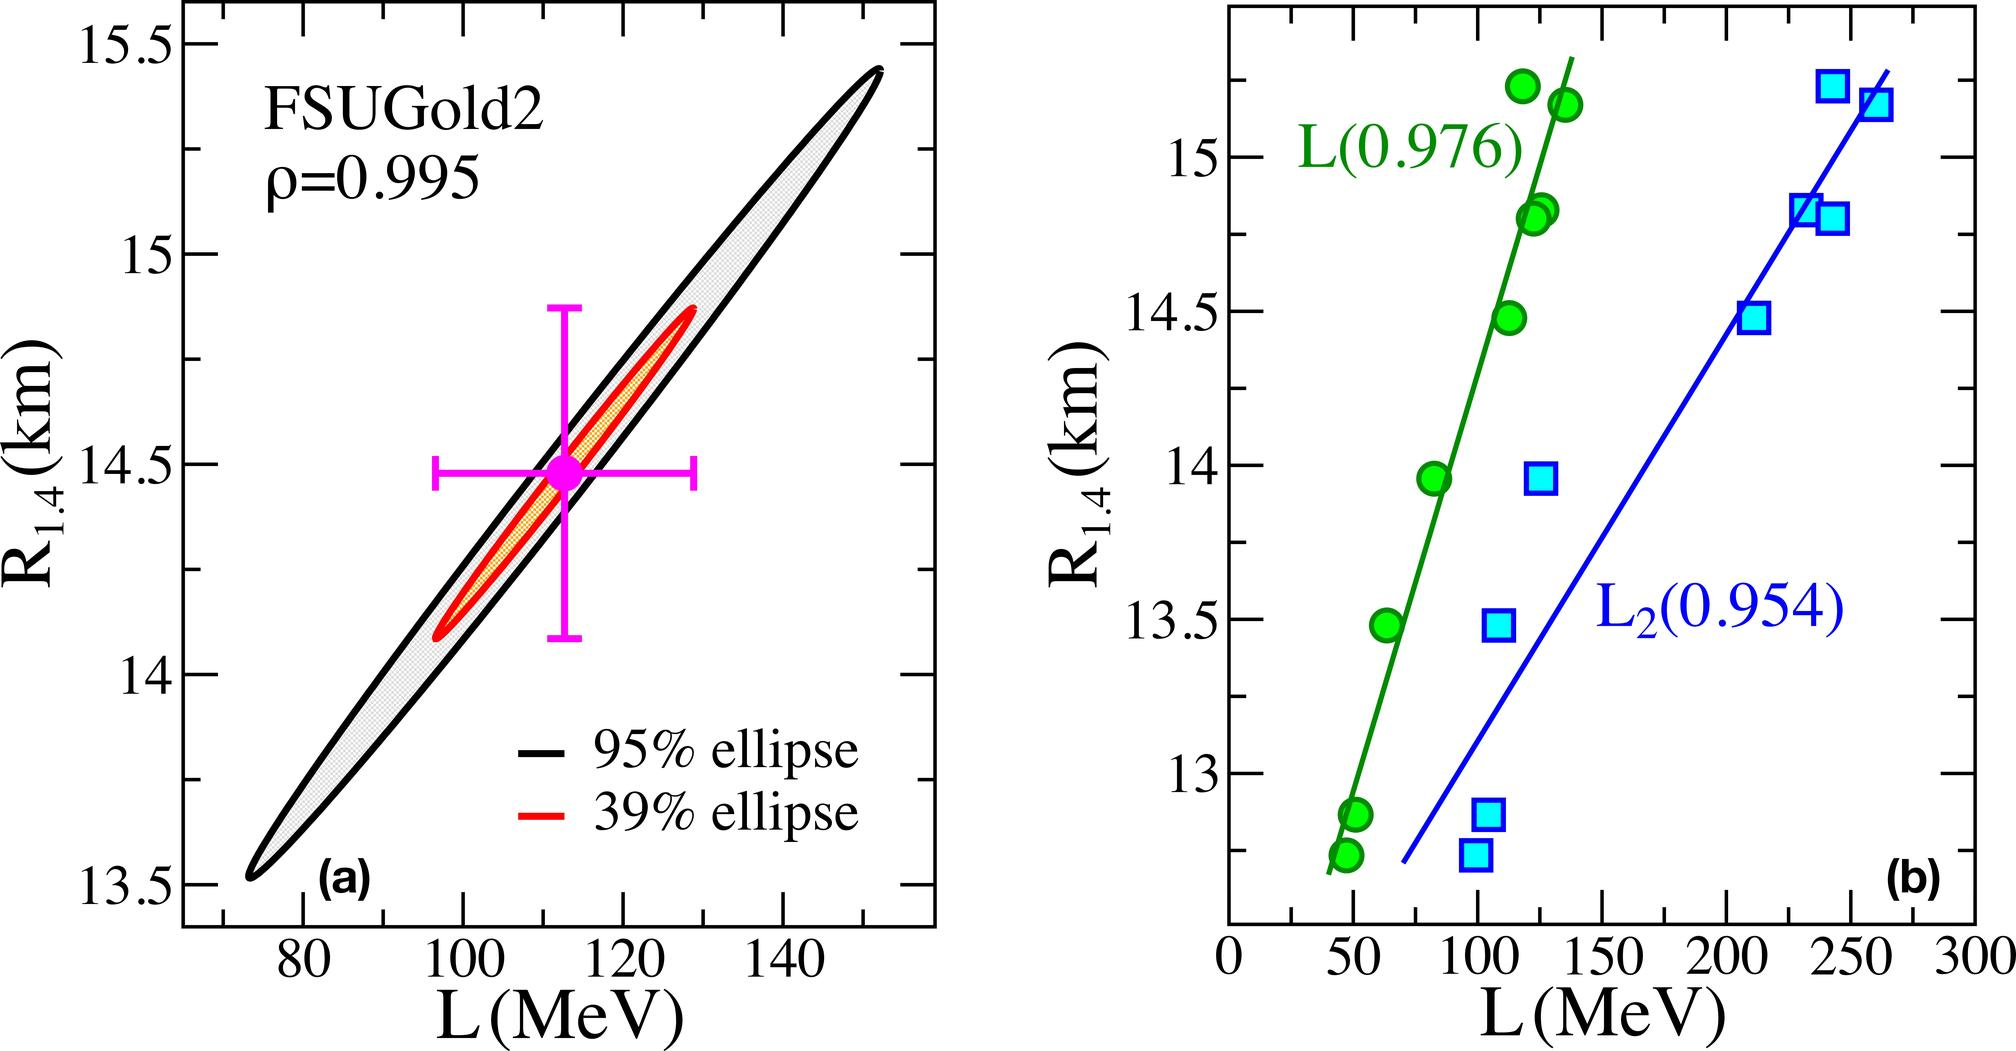Can you explain why the FSUGold2 model uses such specific L values, as seen in the graph? The specific L values shown in the FSUGold2 graph refer to the slope of the nuclear symmetry energy at saturation density. These values are crucial for modeling the equation of state of nuclear matter, particularly in the context of neutron stars. Different L values affect the predictions of neutron star properties like the radius and mass. The L values in FSUGold2 are chosen to explore how variations in this parameter influence the neutron star characteristics, helping to understand more about nuclear interactions under extreme conditions. 